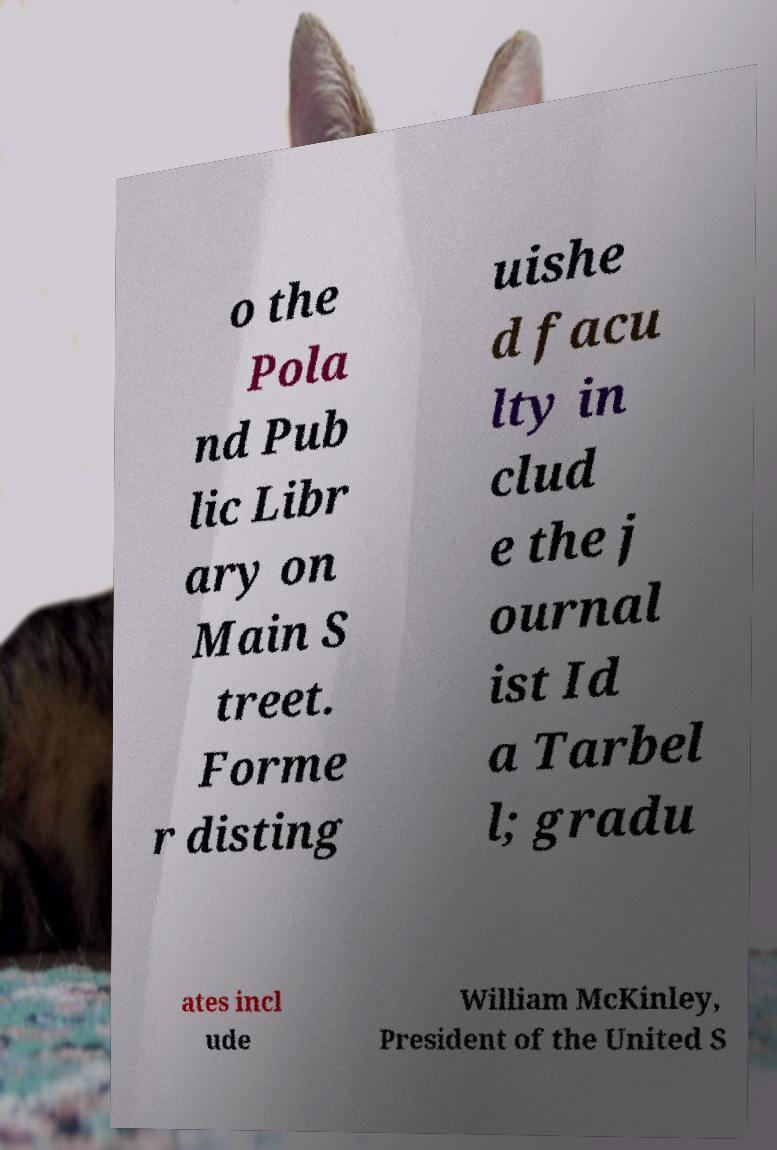For documentation purposes, I need the text within this image transcribed. Could you provide that? o the Pola nd Pub lic Libr ary on Main S treet. Forme r disting uishe d facu lty in clud e the j ournal ist Id a Tarbel l; gradu ates incl ude William McKinley, President of the United S 